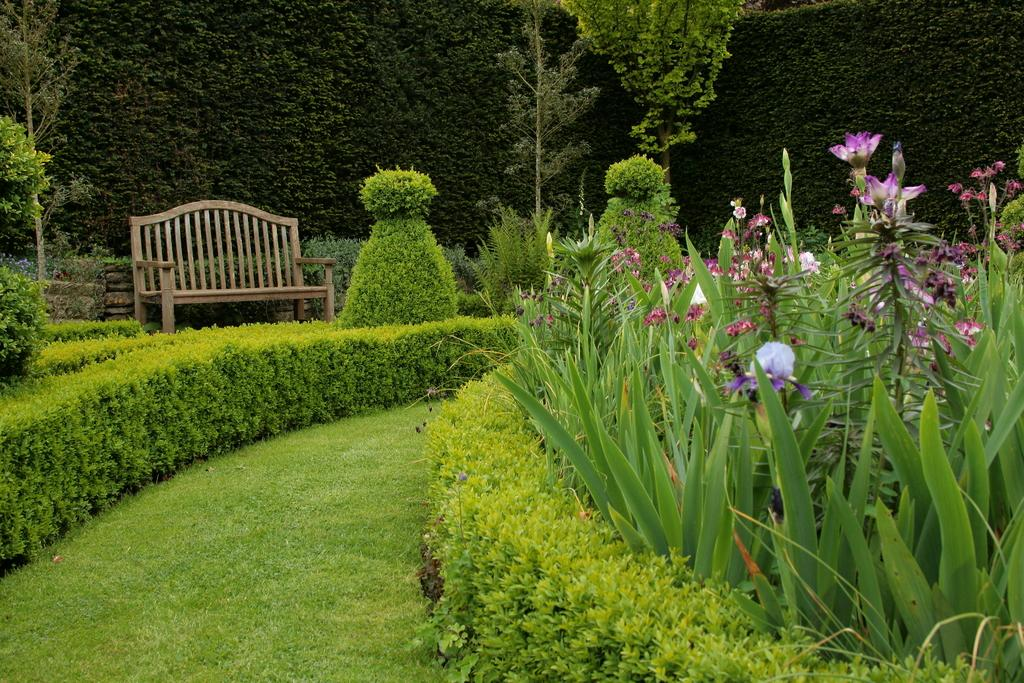What type of area is depicted in the image? There is a garden in the image. What can be seen on the right side of the garden? There are flower plants on the right side of the garden. What is on the left side of the garden? There is grass on the left side of the garden. What type of seating is available in the garden? There is a wooden bench at the back of the garden. What is the backdrop of the garden? There is a grass wall at the back of the garden. What type of pancake is being served on the wooden bench in the image? There is no pancake present in the image; it is a garden with a wooden bench and other elements. 